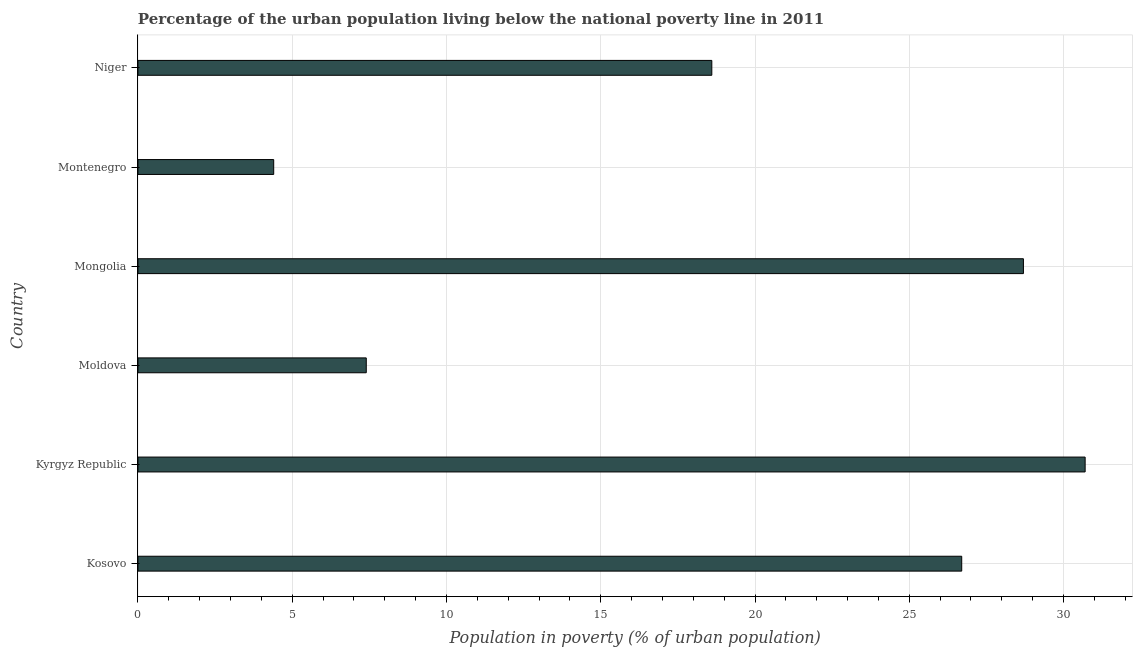Does the graph contain grids?
Keep it short and to the point. Yes. What is the title of the graph?
Your answer should be compact. Percentage of the urban population living below the national poverty line in 2011. What is the label or title of the X-axis?
Your answer should be compact. Population in poverty (% of urban population). What is the label or title of the Y-axis?
Provide a short and direct response. Country. What is the percentage of urban population living below poverty line in Kosovo?
Give a very brief answer. 26.7. Across all countries, what is the maximum percentage of urban population living below poverty line?
Provide a short and direct response. 30.7. Across all countries, what is the minimum percentage of urban population living below poverty line?
Ensure brevity in your answer.  4.4. In which country was the percentage of urban population living below poverty line maximum?
Keep it short and to the point. Kyrgyz Republic. In which country was the percentage of urban population living below poverty line minimum?
Provide a short and direct response. Montenegro. What is the sum of the percentage of urban population living below poverty line?
Offer a very short reply. 116.5. What is the average percentage of urban population living below poverty line per country?
Provide a short and direct response. 19.42. What is the median percentage of urban population living below poverty line?
Your answer should be compact. 22.65. In how many countries, is the percentage of urban population living below poverty line greater than 14 %?
Your answer should be compact. 4. What is the ratio of the percentage of urban population living below poverty line in Kosovo to that in Kyrgyz Republic?
Make the answer very short. 0.87. Is the percentage of urban population living below poverty line in Kosovo less than that in Kyrgyz Republic?
Provide a succinct answer. Yes. Is the difference between the percentage of urban population living below poverty line in Kyrgyz Republic and Moldova greater than the difference between any two countries?
Ensure brevity in your answer.  No. Is the sum of the percentage of urban population living below poverty line in Kosovo and Kyrgyz Republic greater than the maximum percentage of urban population living below poverty line across all countries?
Keep it short and to the point. Yes. What is the difference between the highest and the lowest percentage of urban population living below poverty line?
Your response must be concise. 26.3. How many bars are there?
Offer a very short reply. 6. What is the difference between two consecutive major ticks on the X-axis?
Provide a short and direct response. 5. Are the values on the major ticks of X-axis written in scientific E-notation?
Provide a succinct answer. No. What is the Population in poverty (% of urban population) of Kosovo?
Give a very brief answer. 26.7. What is the Population in poverty (% of urban population) in Kyrgyz Republic?
Provide a short and direct response. 30.7. What is the Population in poverty (% of urban population) in Moldova?
Your response must be concise. 7.4. What is the Population in poverty (% of urban population) in Mongolia?
Your answer should be compact. 28.7. What is the Population in poverty (% of urban population) in Montenegro?
Keep it short and to the point. 4.4. What is the Population in poverty (% of urban population) of Niger?
Your response must be concise. 18.6. What is the difference between the Population in poverty (% of urban population) in Kosovo and Moldova?
Ensure brevity in your answer.  19.3. What is the difference between the Population in poverty (% of urban population) in Kosovo and Montenegro?
Provide a succinct answer. 22.3. What is the difference between the Population in poverty (% of urban population) in Kyrgyz Republic and Moldova?
Make the answer very short. 23.3. What is the difference between the Population in poverty (% of urban population) in Kyrgyz Republic and Mongolia?
Offer a terse response. 2. What is the difference between the Population in poverty (% of urban population) in Kyrgyz Republic and Montenegro?
Provide a short and direct response. 26.3. What is the difference between the Population in poverty (% of urban population) in Kyrgyz Republic and Niger?
Your response must be concise. 12.1. What is the difference between the Population in poverty (% of urban population) in Moldova and Mongolia?
Your answer should be very brief. -21.3. What is the difference between the Population in poverty (% of urban population) in Moldova and Montenegro?
Offer a very short reply. 3. What is the difference between the Population in poverty (% of urban population) in Mongolia and Montenegro?
Offer a very short reply. 24.3. What is the difference between the Population in poverty (% of urban population) in Mongolia and Niger?
Make the answer very short. 10.1. What is the difference between the Population in poverty (% of urban population) in Montenegro and Niger?
Your response must be concise. -14.2. What is the ratio of the Population in poverty (% of urban population) in Kosovo to that in Kyrgyz Republic?
Provide a short and direct response. 0.87. What is the ratio of the Population in poverty (% of urban population) in Kosovo to that in Moldova?
Your answer should be compact. 3.61. What is the ratio of the Population in poverty (% of urban population) in Kosovo to that in Mongolia?
Keep it short and to the point. 0.93. What is the ratio of the Population in poverty (% of urban population) in Kosovo to that in Montenegro?
Keep it short and to the point. 6.07. What is the ratio of the Population in poverty (% of urban population) in Kosovo to that in Niger?
Your answer should be very brief. 1.44. What is the ratio of the Population in poverty (% of urban population) in Kyrgyz Republic to that in Moldova?
Offer a terse response. 4.15. What is the ratio of the Population in poverty (% of urban population) in Kyrgyz Republic to that in Mongolia?
Ensure brevity in your answer.  1.07. What is the ratio of the Population in poverty (% of urban population) in Kyrgyz Republic to that in Montenegro?
Provide a succinct answer. 6.98. What is the ratio of the Population in poverty (% of urban population) in Kyrgyz Republic to that in Niger?
Make the answer very short. 1.65. What is the ratio of the Population in poverty (% of urban population) in Moldova to that in Mongolia?
Your answer should be very brief. 0.26. What is the ratio of the Population in poverty (% of urban population) in Moldova to that in Montenegro?
Your answer should be compact. 1.68. What is the ratio of the Population in poverty (% of urban population) in Moldova to that in Niger?
Your answer should be very brief. 0.4. What is the ratio of the Population in poverty (% of urban population) in Mongolia to that in Montenegro?
Provide a succinct answer. 6.52. What is the ratio of the Population in poverty (% of urban population) in Mongolia to that in Niger?
Offer a terse response. 1.54. What is the ratio of the Population in poverty (% of urban population) in Montenegro to that in Niger?
Give a very brief answer. 0.24. 